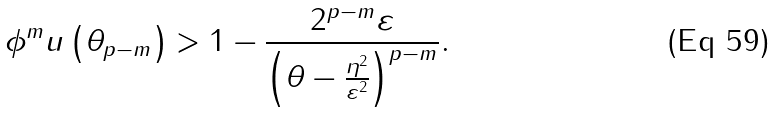Convert formula to latex. <formula><loc_0><loc_0><loc_500><loc_500>\phi ^ { m } u \left ( \theta _ { p - m } \right ) > 1 - \frac { 2 ^ { p - m } \varepsilon } { \left ( \theta - \frac { \eta ^ { 2 } } { \varepsilon ^ { 2 } } \right ) ^ { p - m } } .</formula> 